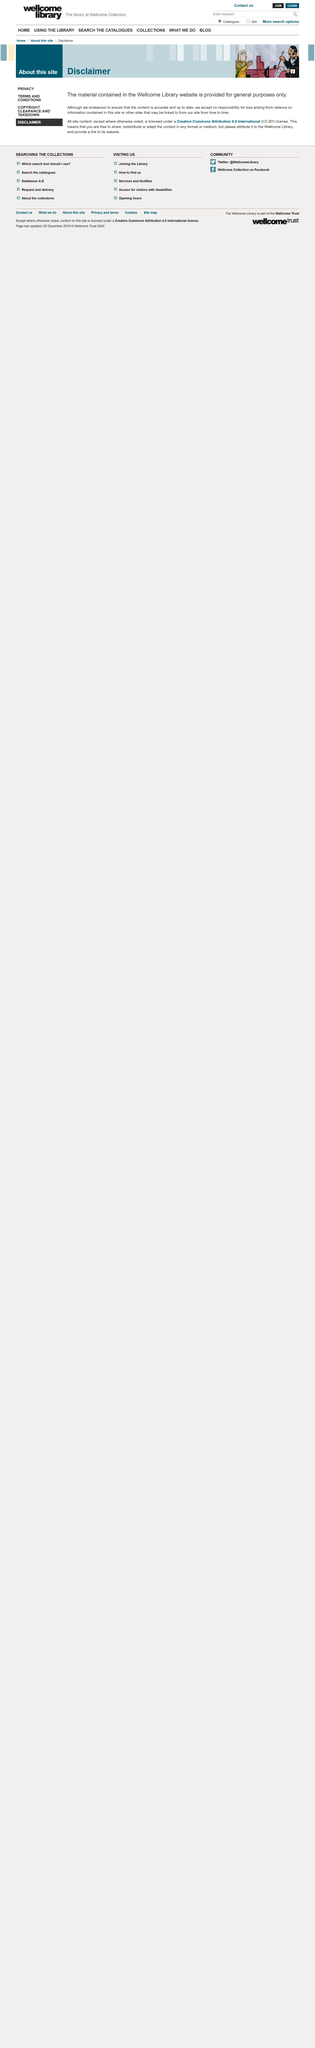Draw attention to some important aspects in this diagram. The material on the Wellcome Library website is provided for general purposes only and is not intended for any specific use. The content on the website is licensed under a Creative Commons Attribution 4.0 International license. The article is about the Wellcome Library. 